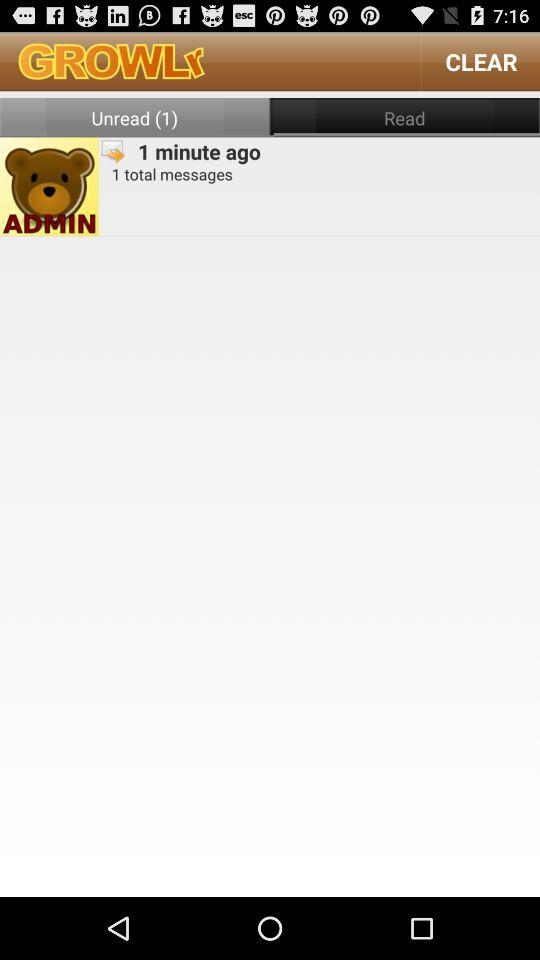How long ago was the message received? The message was received 1 minute ago. 